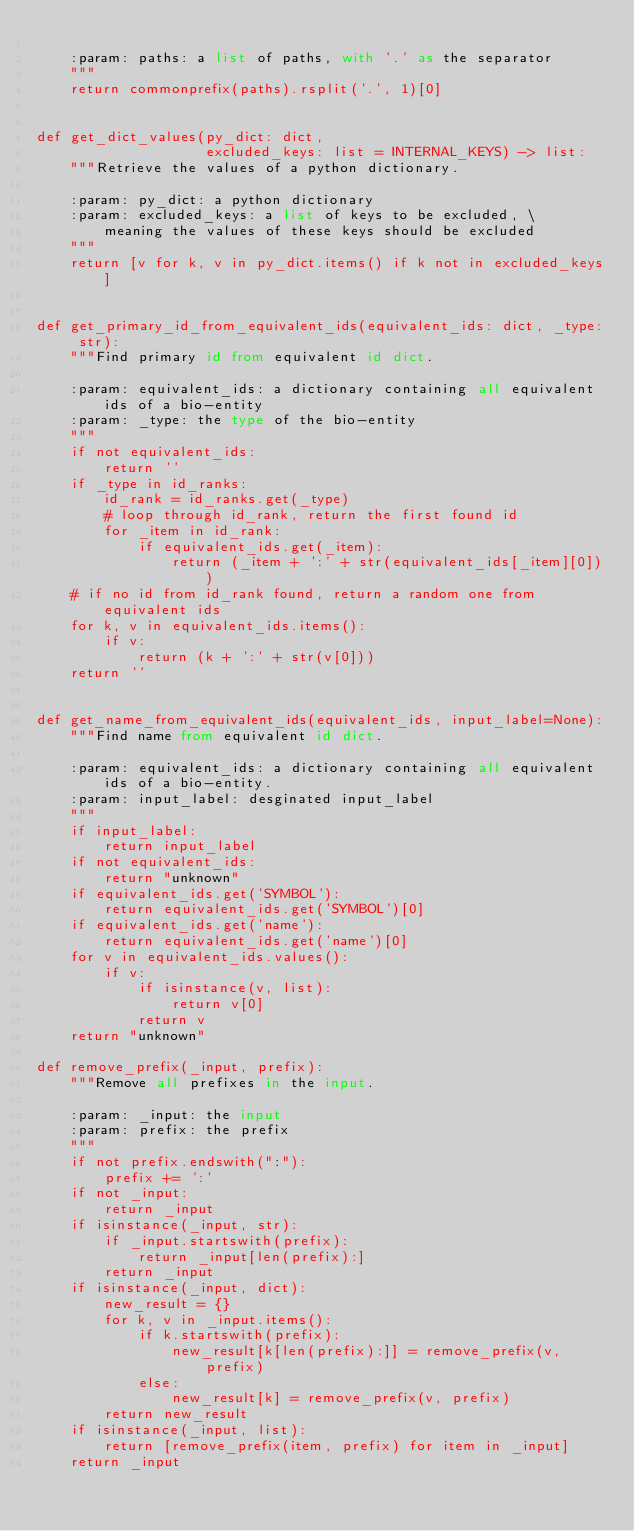<code> <loc_0><loc_0><loc_500><loc_500><_Python_>
    :param: paths: a list of paths, with '.' as the separator
    """
    return commonprefix(paths).rsplit('.', 1)[0]


def get_dict_values(py_dict: dict,
                    excluded_keys: list = INTERNAL_KEYS) -> list:
    """Retrieve the values of a python dictionary.

    :param: py_dict: a python dictionary
    :param: excluded_keys: a list of keys to be excluded, \
        meaning the values of these keys should be excluded
    """
    return [v for k, v in py_dict.items() if k not in excluded_keys]


def get_primary_id_from_equivalent_ids(equivalent_ids: dict, _type: str):
    """Find primary id from equivalent id dict.

    :param: equivalent_ids: a dictionary containing all equivalent ids of a bio-entity
    :param: _type: the type of the bio-entity
    """
    if not equivalent_ids:
        return ''
    if _type in id_ranks:
        id_rank = id_ranks.get(_type)
        # loop through id_rank, return the first found id
        for _item in id_rank:
            if equivalent_ids.get(_item):
                return (_item + ':' + str(equivalent_ids[_item][0]))
    # if no id from id_rank found, return a random one from equivalent ids
    for k, v in equivalent_ids.items():
        if v:
            return (k + ':' + str(v[0]))
    return ''


def get_name_from_equivalent_ids(equivalent_ids, input_label=None):
    """Find name from equivalent id dict.

    :param: equivalent_ids: a dictionary containing all equivalent ids of a bio-entity.
    :param: input_label: desginated input_label
    """
    if input_label:
        return input_label
    if not equivalent_ids:
        return "unknown"
    if equivalent_ids.get('SYMBOL'):
        return equivalent_ids.get('SYMBOL')[0]
    if equivalent_ids.get('name'):
        return equivalent_ids.get('name')[0]
    for v in equivalent_ids.values():
        if v:
            if isinstance(v, list):
                return v[0]
            return v
    return "unknown"

def remove_prefix(_input, prefix):
    """Remove all prefixes in the input.
    
    :param: _input: the input
    :param: prefix: the prefix
    """
    if not prefix.endswith(":"):
        prefix += ':'
    if not _input:
        return _input
    if isinstance(_input, str):
        if _input.startswith(prefix):
            return _input[len(prefix):]
        return _input
    if isinstance(_input, dict):
        new_result = {}
        for k, v in _input.items():
            if k.startswith(prefix):
                new_result[k[len(prefix):]] = remove_prefix(v, prefix)
            else:
                new_result[k] = remove_prefix(v, prefix)
        return new_result
    if isinstance(_input, list):
        return [remove_prefix(item, prefix) for item in _input]
    return _input
</code> 